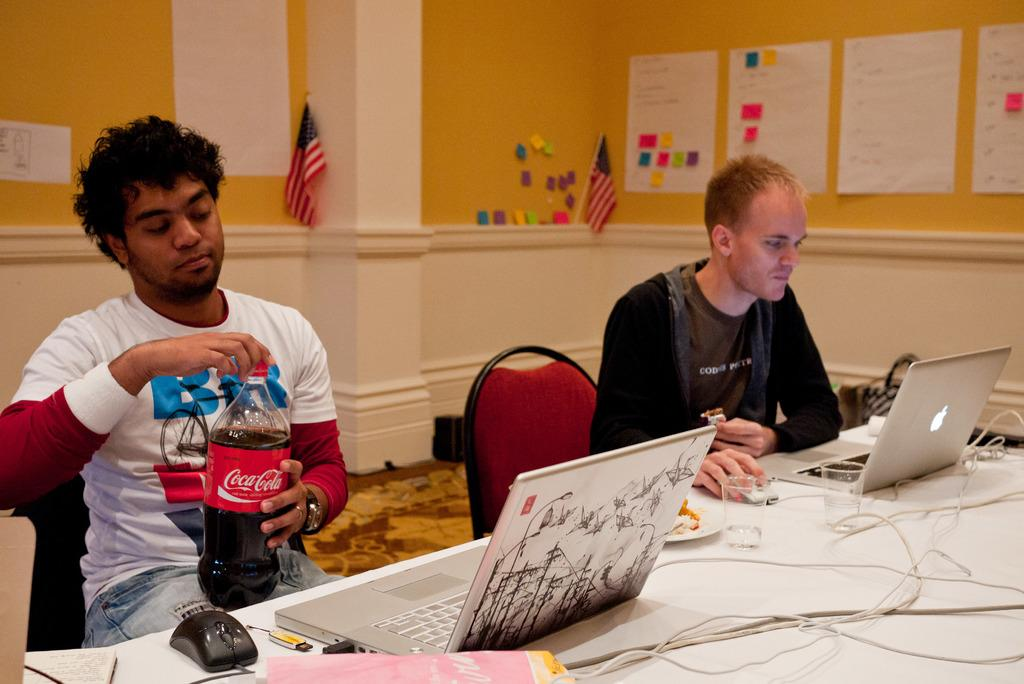How many people are in the image? There are two men in the image. What are the men holding in the image? One man is holding a coke bottle, and the other man is holding chocolate. What activity are the men engaged in? Both men are operating a laptop. What can be seen on the wall in the image? There is a chart paper on the wall. What additional object is present in the image? There is a flag in the image. Is there a woman on the team in the image? There is no woman present in the image; it features two men. What shape is the circle that the men are discussing in the image? There is no mention of a circle or any discussion about a circle in the image. 